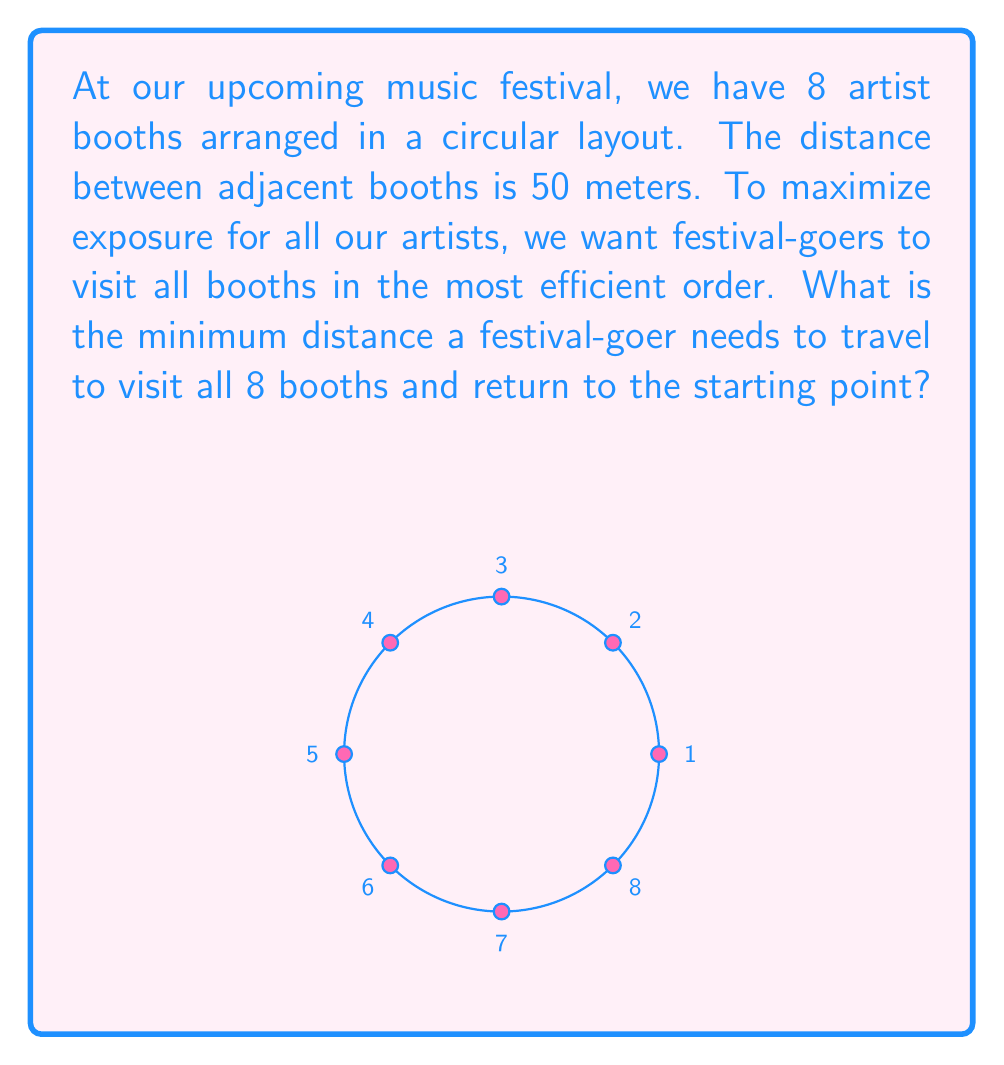What is the answer to this math problem? Let's approach this step-by-step:

1) First, we need to recognize that this problem is essentially asking for the shortest path that visits all vertices of a regular octagon and returns to the starting point. This is a classic Traveling Salesman Problem (TSP).

2) In a regular polygon with equal distances between adjacent vertices, the optimal solution for TSP is always to visit the vertices in order, either clockwise or counterclockwise.

3) The perimeter of the octagon represents the total distance traveled:
   
   $$\text{Total Distance} = 8 \times \text{Distance between adjacent booths}$$

4) We're given that the distance between adjacent booths is 50 meters. So:

   $$\text{Total Distance} = 8 \times 50 \text{ meters}$$

5) Calculate the final result:

   $$\text{Total Distance} = 400 \text{ meters}$$

Therefore, the minimum distance a festival-goer needs to travel to visit all 8 booths and return to the starting point is 400 meters.
Answer: 400 meters 